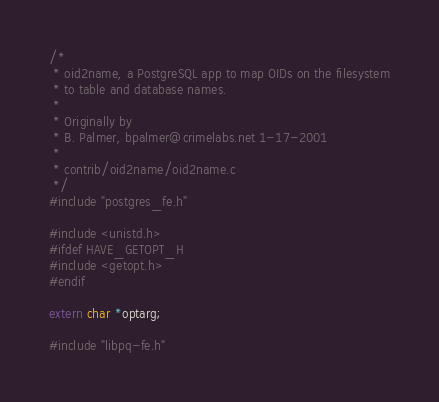<code> <loc_0><loc_0><loc_500><loc_500><_C_>/*
 * oid2name, a PostgreSQL app to map OIDs on the filesystem
 * to table and database names.
 *
 * Originally by
 * B. Palmer, bpalmer@crimelabs.net 1-17-2001
 *
 * contrib/oid2name/oid2name.c
 */
#include "postgres_fe.h"

#include <unistd.h>
#ifdef HAVE_GETOPT_H
#include <getopt.h>
#endif

extern char *optarg;

#include "libpq-fe.h"
</code> 